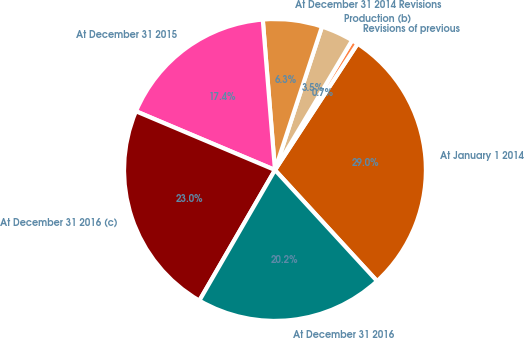Convert chart. <chart><loc_0><loc_0><loc_500><loc_500><pie_chart><fcel>At January 1 2014<fcel>Revisions of previous<fcel>Production (b)<fcel>At December 31 2014 Revisions<fcel>At December 31 2015<fcel>At December 31 2016 (c)<fcel>At December 31 2016<nl><fcel>28.95%<fcel>0.68%<fcel>3.5%<fcel>6.33%<fcel>17.35%<fcel>23.01%<fcel>20.18%<nl></chart> 